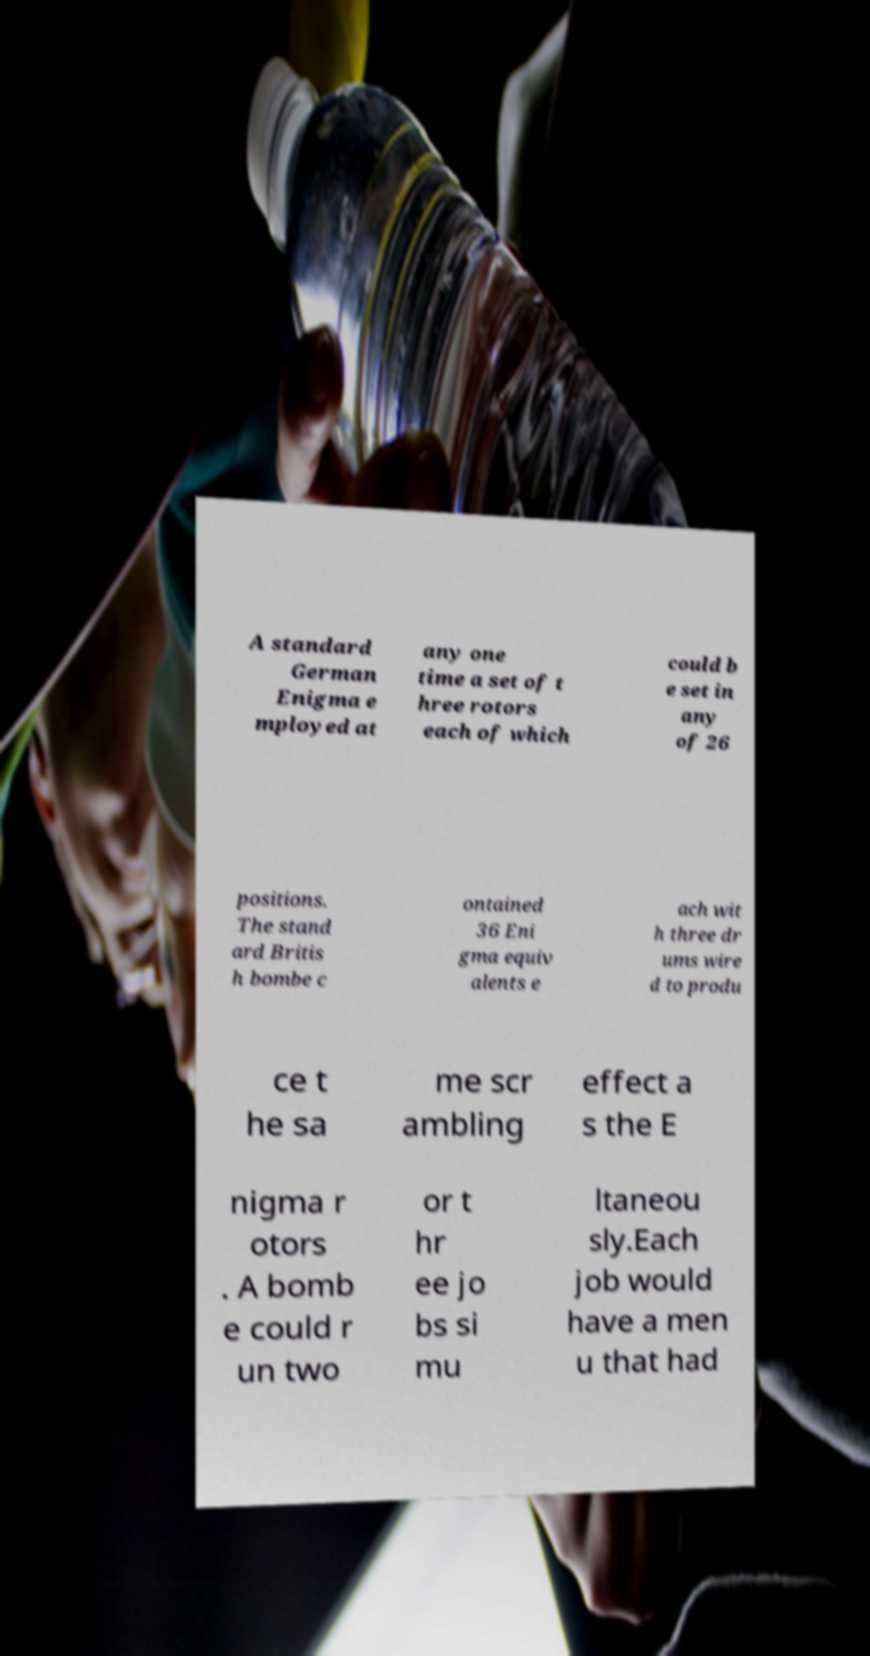There's text embedded in this image that I need extracted. Can you transcribe it verbatim? A standard German Enigma e mployed at any one time a set of t hree rotors each of which could b e set in any of 26 positions. The stand ard Britis h bombe c ontained 36 Eni gma equiv alents e ach wit h three dr ums wire d to produ ce t he sa me scr ambling effect a s the E nigma r otors . A bomb e could r un two or t hr ee jo bs si mu ltaneou sly.Each job would have a men u that had 